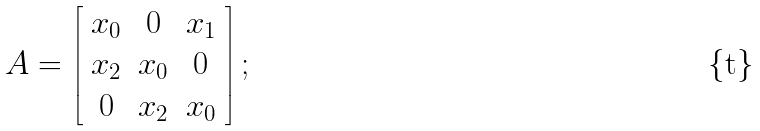Convert formula to latex. <formula><loc_0><loc_0><loc_500><loc_500>A = \left [ \begin{array} { c c c } x _ { 0 } & 0 & x _ { 1 } \\ x _ { 2 } & x _ { 0 } & 0 \\ 0 & x _ { 2 } & x _ { 0 } \end{array} \right ] ;</formula> 